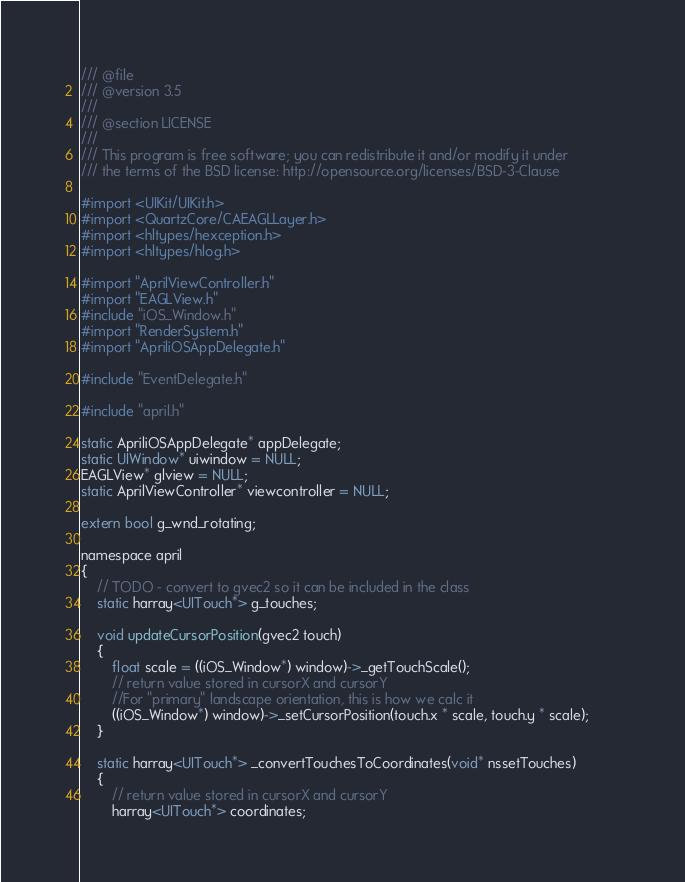Convert code to text. <code><loc_0><loc_0><loc_500><loc_500><_ObjectiveC_>/// @file
/// @version 3.5
/// 
/// @section LICENSE
/// 
/// This program is free software; you can redistribute it and/or modify it under
/// the terms of the BSD license: http://opensource.org/licenses/BSD-3-Clause

#import <UIKit/UIKit.h>
#import <QuartzCore/CAEAGLLayer.h>
#import <hltypes/hexception.h>
#import <hltypes/hlog.h>

#import "AprilViewController.h"
#import "EAGLView.h"
#include "iOS_Window.h"
#import "RenderSystem.h"
#import "ApriliOSAppDelegate.h"

#include "EventDelegate.h"

#include "april.h"

static ApriliOSAppDelegate* appDelegate;
static UIWindow* uiwindow = NULL;
EAGLView* glview = NULL;
static AprilViewController* viewcontroller = NULL;

extern bool g_wnd_rotating;

namespace april
{
	// TODO - convert to gvec2 so it can be included in the class
	static harray<UITouch*> g_touches;
	
	void updateCursorPosition(gvec2 touch)
	{
		float scale = ((iOS_Window*) window)->_getTouchScale();
		// return value stored in cursorX and cursorY		
		//For "primary" landscape orientation, this is how we calc it
		((iOS_Window*) window)->_setCursorPosition(touch.x * scale, touch.y * scale);		
	}
	
	static harray<UITouch*> _convertTouchesToCoordinates(void* nssetTouches)
	{
		// return value stored in cursorX and cursorY
		harray<UITouch*> coordinates;</code> 